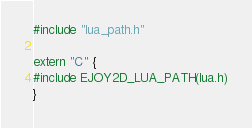<code> <loc_0><loc_0><loc_500><loc_500><_C_>#include "lua_path.h"

extern "C" {
#include EJOY2D_LUA_PATH(lua.h)
}
</code> 